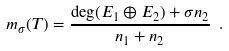Convert formula to latex. <formula><loc_0><loc_0><loc_500><loc_500>\ m _ { \sigma } ( T ) = \frac { \deg ( E _ { 1 } \oplus E _ { 2 } ) + \sigma n _ { 2 } } { n _ { 1 } + n _ { 2 } } \ .</formula> 